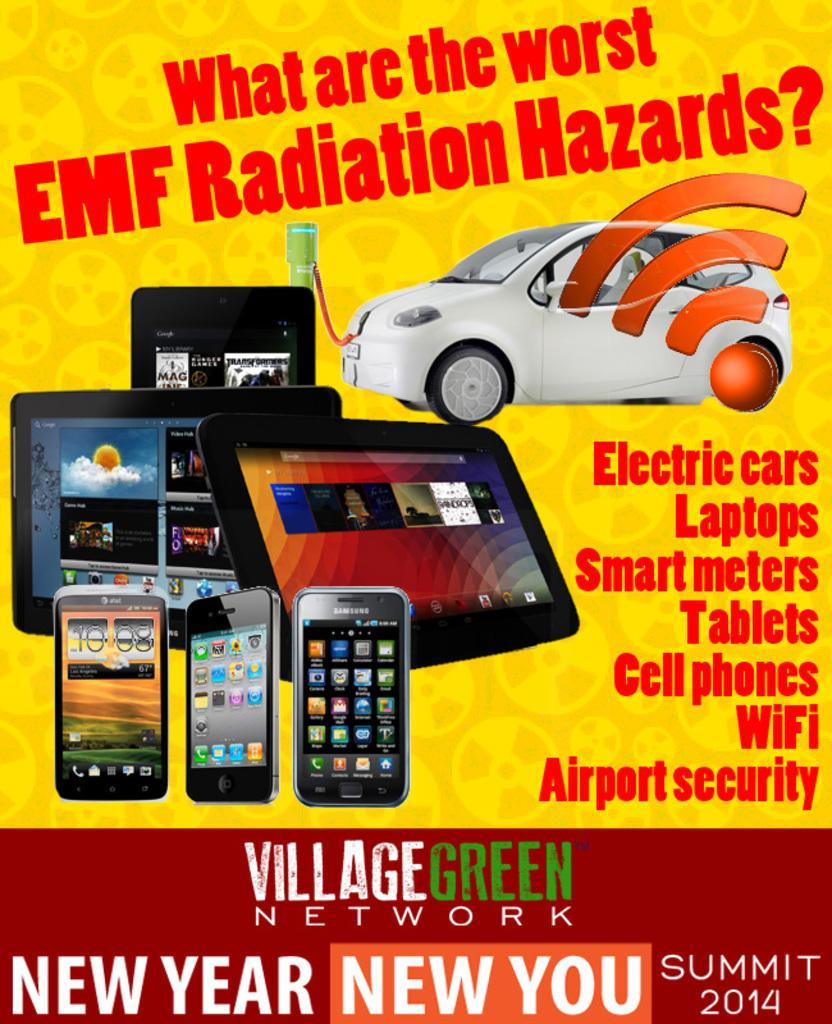Please provide a concise description of this image. In this image we can see a poster which is in yellow and red color on which we can see mobile phones, tablets, white color car and some edited text on it. 